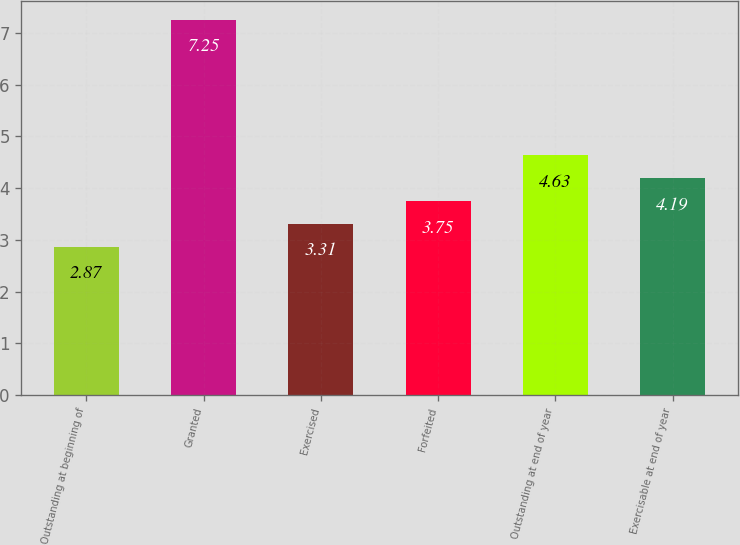Convert chart. <chart><loc_0><loc_0><loc_500><loc_500><bar_chart><fcel>Outstanding at beginning of<fcel>Granted<fcel>Exercised<fcel>Forfeited<fcel>Outstanding at end of year<fcel>Exercisable at end of year<nl><fcel>2.87<fcel>7.25<fcel>3.31<fcel>3.75<fcel>4.63<fcel>4.19<nl></chart> 